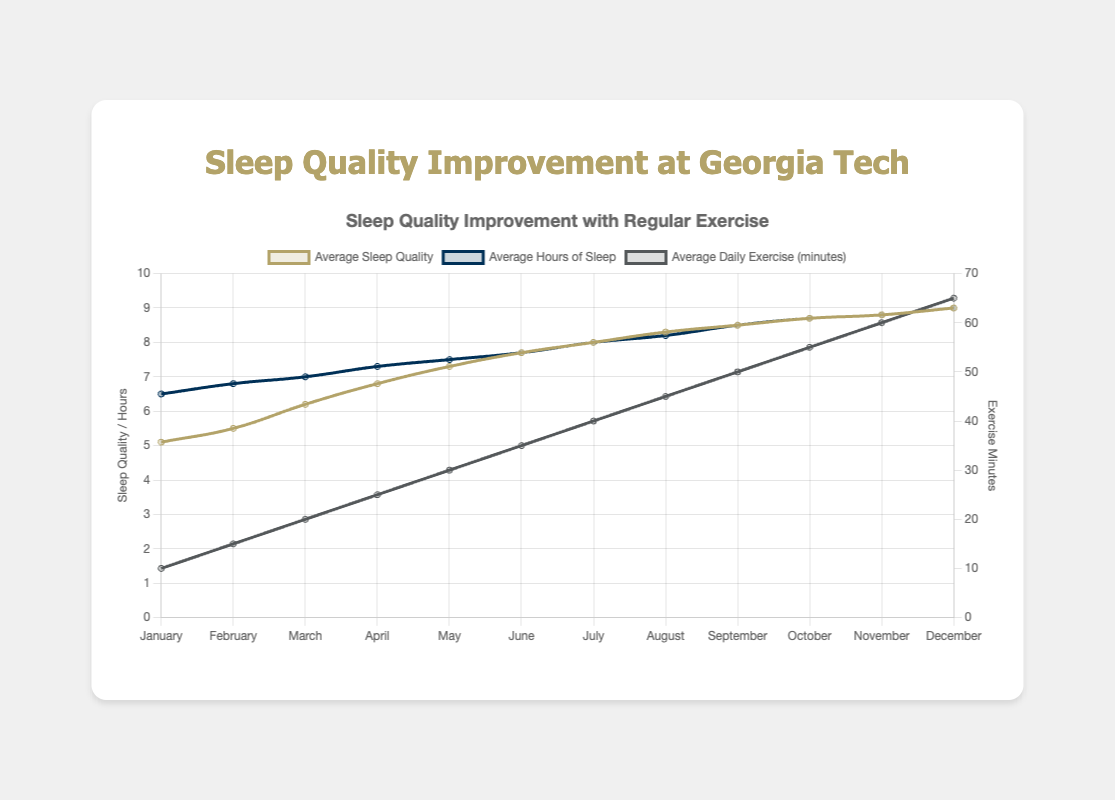What is the average sleep quality in December? Based on the chart, the average sleep quality for December is 9.0, as indicated by the peak of the gold-colored line representing sleep quality.
Answer: 9.0 How many hours of sleep do Georgia Tech freshmen get on average in July? From the blue-colored line representing average hours of sleep, we see it's at 8.0 hours in July.
Answer: 8.0 What is the difference in average daily exercise minutes between March and May? According to the data points on the gray-colored line representing exercise minutes, March has 20 minutes and May has 30 minutes. The difference is 30 - 20 = 10 minutes.
Answer: 10 During which month do students average 7.3 hours of sleep? Looking at the blue-colored line, the point indicating 7.3 hours of sleep falls in April.
Answer: April Does the average sleep quality ever reach 8.5? Yes, according to the gold-colored line, the average sleep quality reaches 8.5 in September.
Answer: Yes Which has more average hours of sleep, January or February? Comparing the heights of the blue-colored line, February has more average hours of sleep (6.8) than January (6.5).
Answer: February What is the sum of average daily exercise minutes in June and October? June has 35 minutes and October has 55 minutes. Summing this up, 35 + 55 = 90 minutes.
Answer: 90 Is there any month where average sleep quality, hours of sleep, and daily exercise minutes are all the same? According to the chart, the only month where all three metrics are the same is December, at 9.0, 9.0, and 65 minutes, respectively.
Answer: No What is the increase in average sleep quality from January to December? Starting at 5.1 in January and ending with 9.0 in December, the increase is 9.0 - 5.1 = 3.9.
Answer: 3.9 